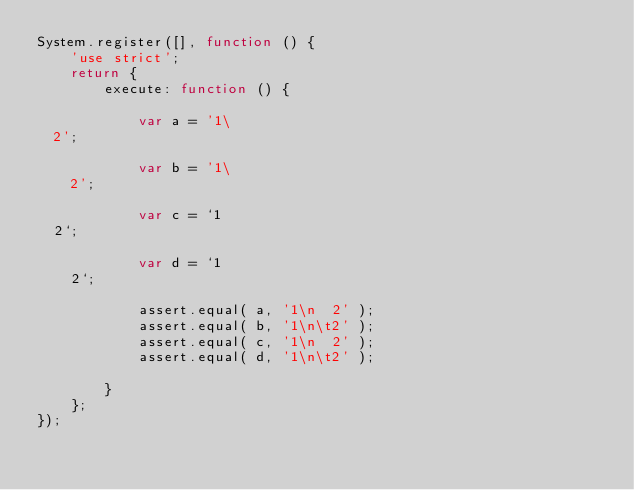Convert code to text. <code><loc_0><loc_0><loc_500><loc_500><_JavaScript_>System.register([], function () {
	'use strict';
	return {
		execute: function () {

			var a = '1\
  2';

			var b = '1\
	2';

			var c = `1
  2`;

			var d = `1
	2`;

			assert.equal( a, '1\n  2' );
			assert.equal( b, '1\n\t2' );
			assert.equal( c, '1\n  2' );
			assert.equal( d, '1\n\t2' );

		}
	};
});
</code> 